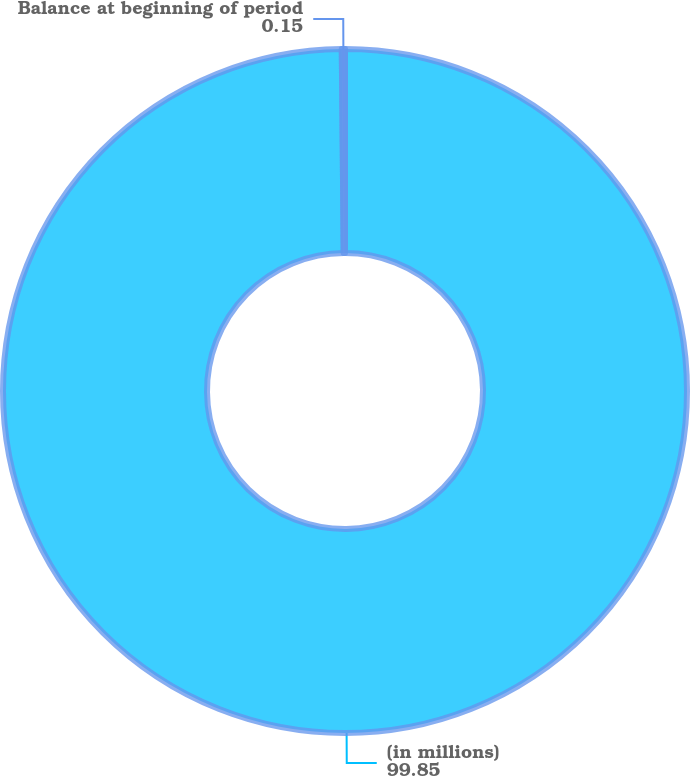Convert chart to OTSL. <chart><loc_0><loc_0><loc_500><loc_500><pie_chart><fcel>(in millions)<fcel>Balance at beginning of period<nl><fcel>99.85%<fcel>0.15%<nl></chart> 